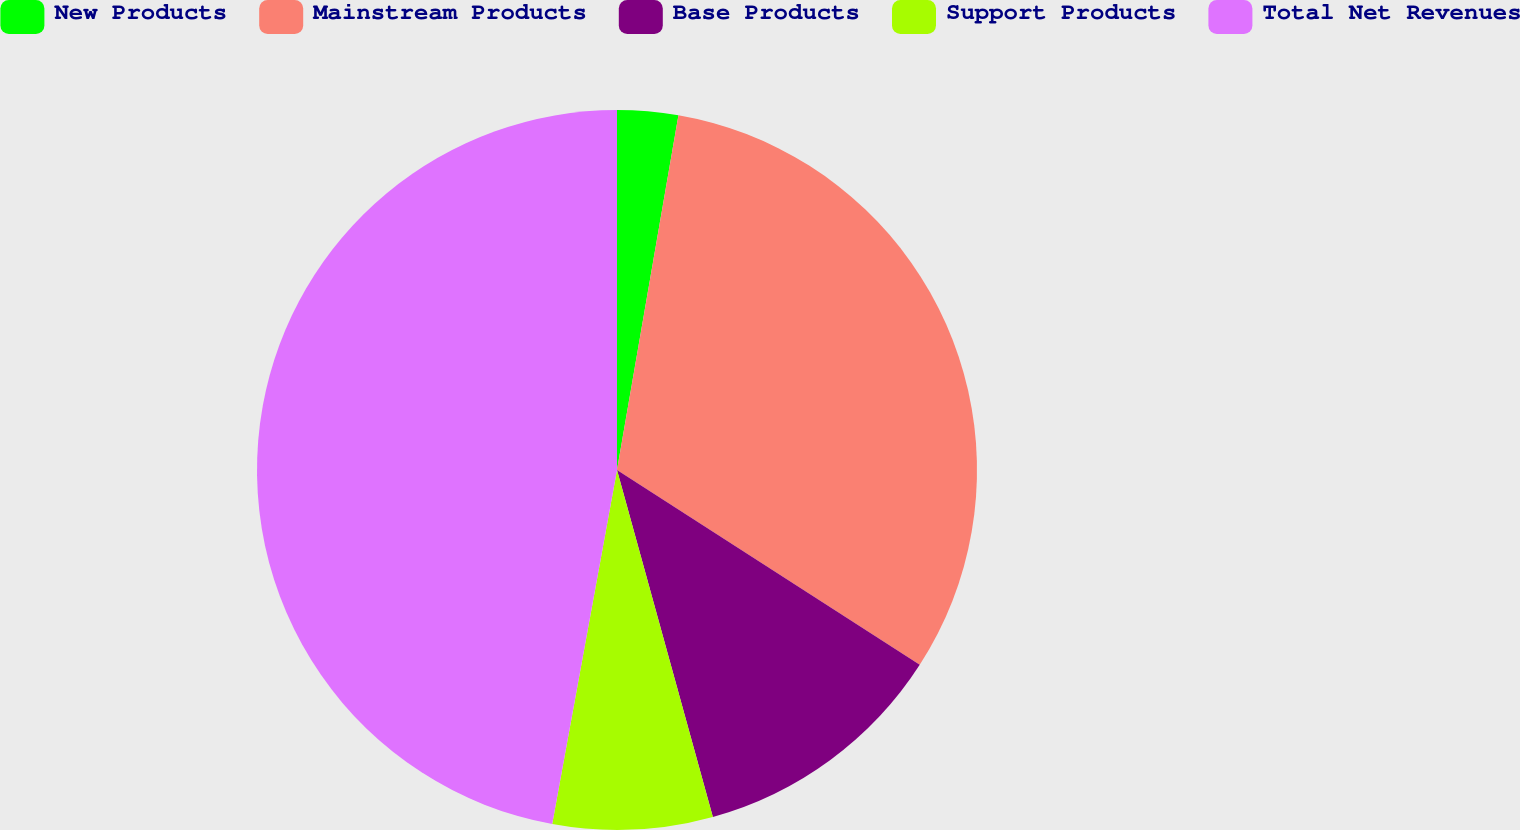Convert chart. <chart><loc_0><loc_0><loc_500><loc_500><pie_chart><fcel>New Products<fcel>Mainstream Products<fcel>Base Products<fcel>Support Products<fcel>Total Net Revenues<nl><fcel>2.73%<fcel>31.37%<fcel>11.61%<fcel>7.17%<fcel>47.12%<nl></chart> 